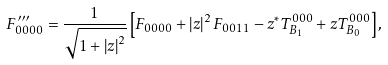Convert formula to latex. <formula><loc_0><loc_0><loc_500><loc_500>F _ { 0 0 0 0 } ^ { \prime \prime \prime } = \frac { 1 } { \sqrt { 1 + \left | z \right | ^ { 2 } } } \left [ F _ { 0 0 0 0 } + \left | z \right | ^ { 2 } F _ { 0 0 1 1 } - z ^ { \ast } T _ { B _ { 1 } } ^ { 0 0 0 } + z T _ { B _ { 0 } } ^ { 0 0 0 } \right ] ,</formula> 